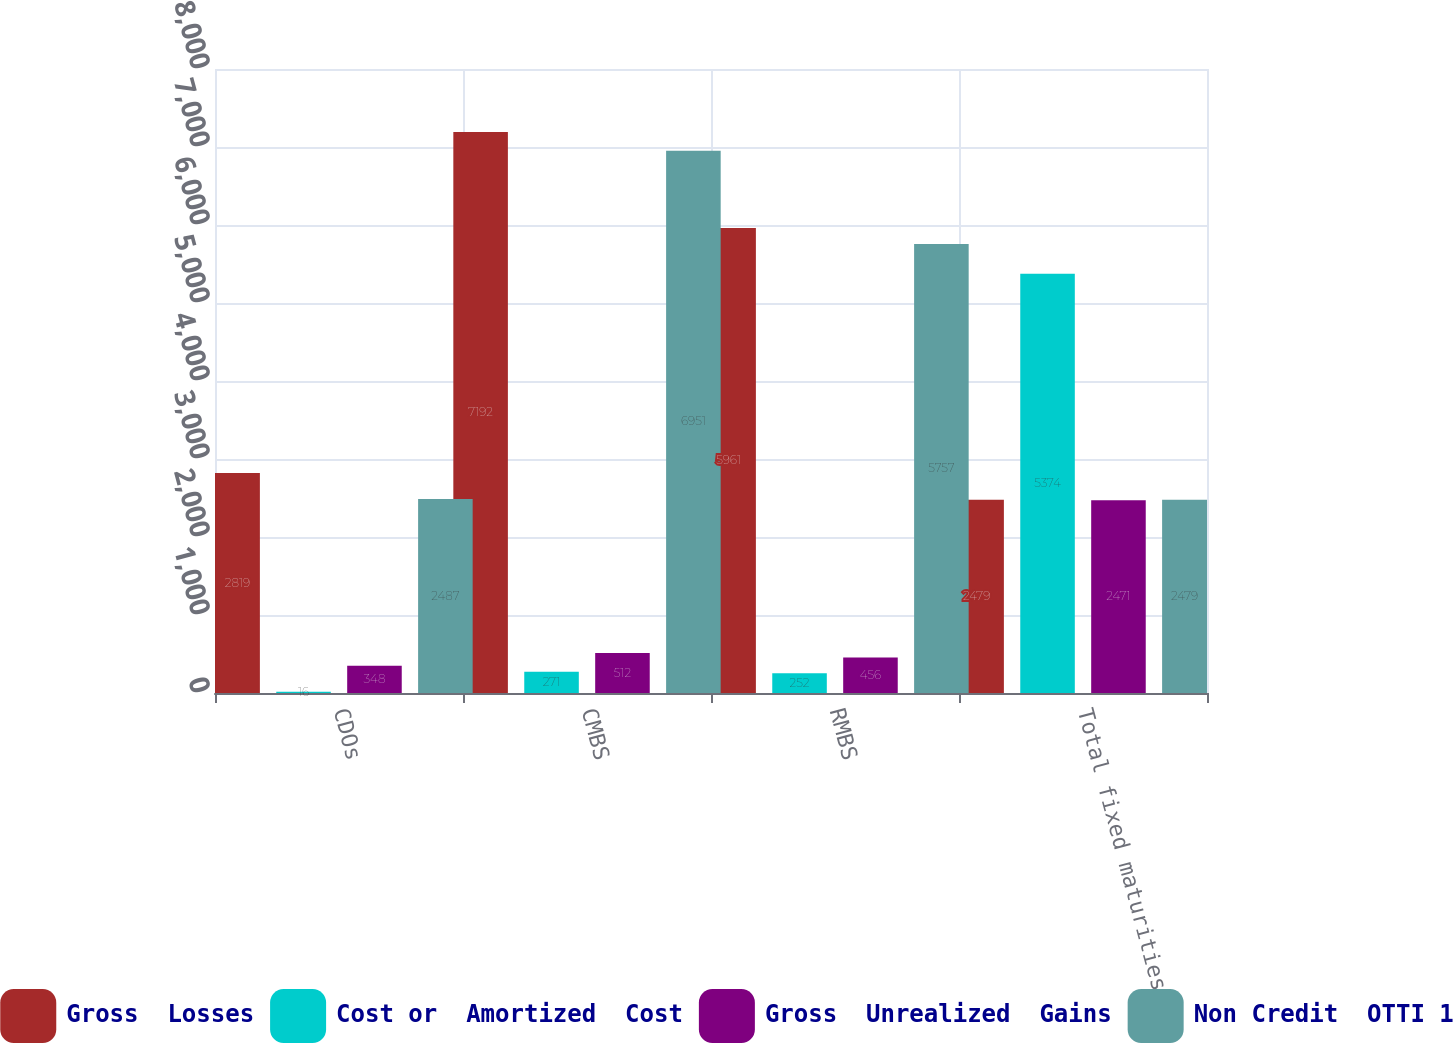<chart> <loc_0><loc_0><loc_500><loc_500><stacked_bar_chart><ecel><fcel>CDOs<fcel>CMBS<fcel>RMBS<fcel>Total fixed maturities AFS<nl><fcel>Gross  Losses<fcel>2819<fcel>7192<fcel>5961<fcel>2479<nl><fcel>Cost or  Amortized  Cost<fcel>16<fcel>271<fcel>252<fcel>5374<nl><fcel>Gross  Unrealized  Gains<fcel>348<fcel>512<fcel>456<fcel>2471<nl><fcel>Non Credit  OTTI 1<fcel>2487<fcel>6951<fcel>5757<fcel>2479<nl></chart> 